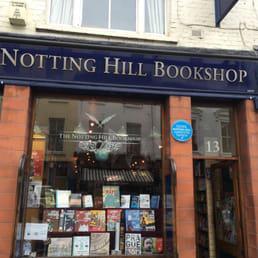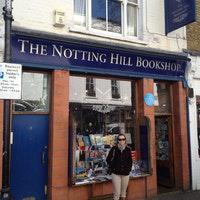The first image is the image on the left, the second image is the image on the right. Evaluate the accuracy of this statement regarding the images: "Two images of the same brick bookshop with blue trim show a large window between two doorways, a person sitting on a window ledge in one image.". Is it true? Answer yes or no. No. The first image is the image on the left, the second image is the image on the right. Assess this claim about the two images: "There is a person sitting down on the ledge along the storefront window.". Correct or not? Answer yes or no. No. 